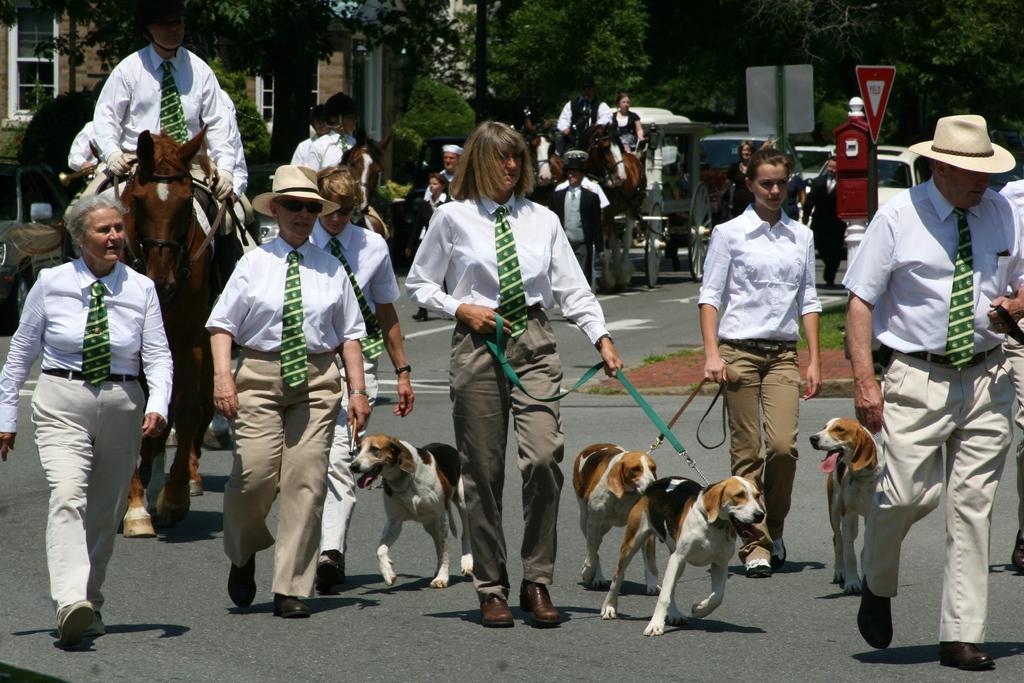In one or two sentences, can you explain what this image depicts? In this picture there are group of people walking and there are dogs walking on the road. At the back there are group of people riding horses on the road and there are vehicles on the road and there is a building and there are trees and plants and there are broads on the poles. At the bottom there is a road and there is grass and ground. 